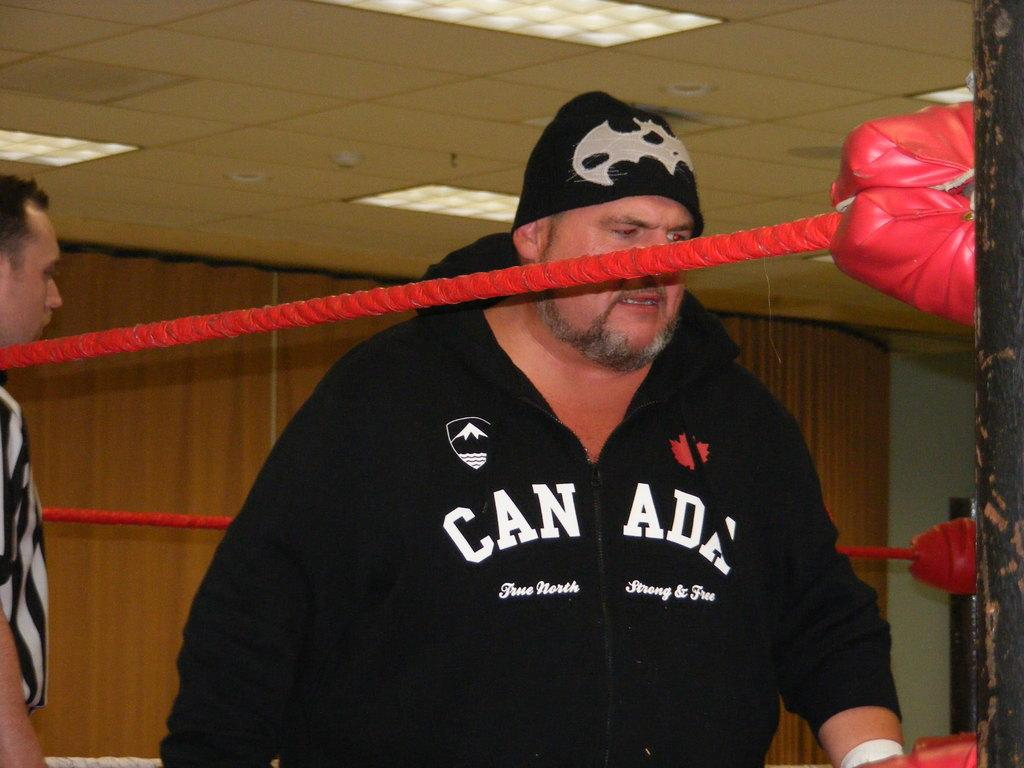Provide a one-sentence caption for the provided image. A man wearing a Canada hooded sweatshirt appears fatigued while standing inside of a boxing ring. 